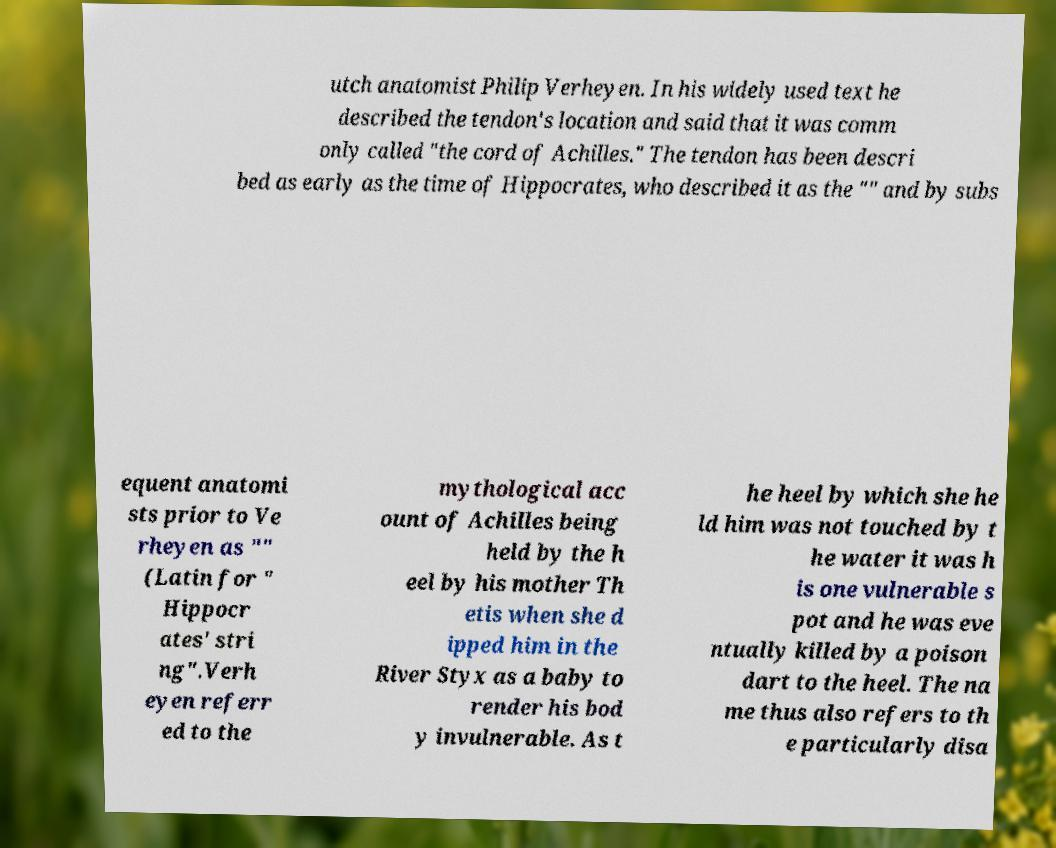Can you read and provide the text displayed in the image?This photo seems to have some interesting text. Can you extract and type it out for me? utch anatomist Philip Verheyen. In his widely used text he described the tendon's location and said that it was comm only called "the cord of Achilles." The tendon has been descri bed as early as the time of Hippocrates, who described it as the "" and by subs equent anatomi sts prior to Ve rheyen as "" (Latin for " Hippocr ates' stri ng".Verh eyen referr ed to the mythological acc ount of Achilles being held by the h eel by his mother Th etis when she d ipped him in the River Styx as a baby to render his bod y invulnerable. As t he heel by which she he ld him was not touched by t he water it was h is one vulnerable s pot and he was eve ntually killed by a poison dart to the heel. The na me thus also refers to th e particularly disa 